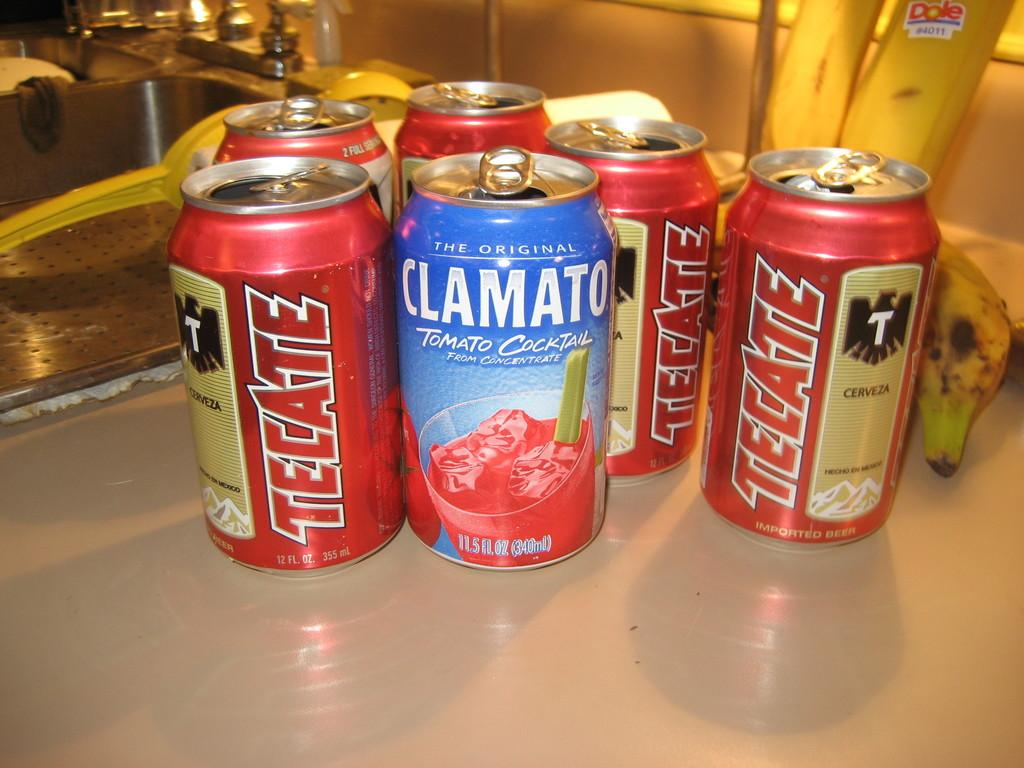<image>
Summarize the visual content of the image. One of the several cans contains Clamato Tomato cocktail 